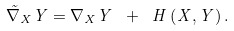Convert formula to latex. <formula><loc_0><loc_0><loc_500><loc_500>\tilde { \nabla } _ { X } Y = \nabla _ { X } Y \ + \ H \left ( X , Y \right ) .</formula> 